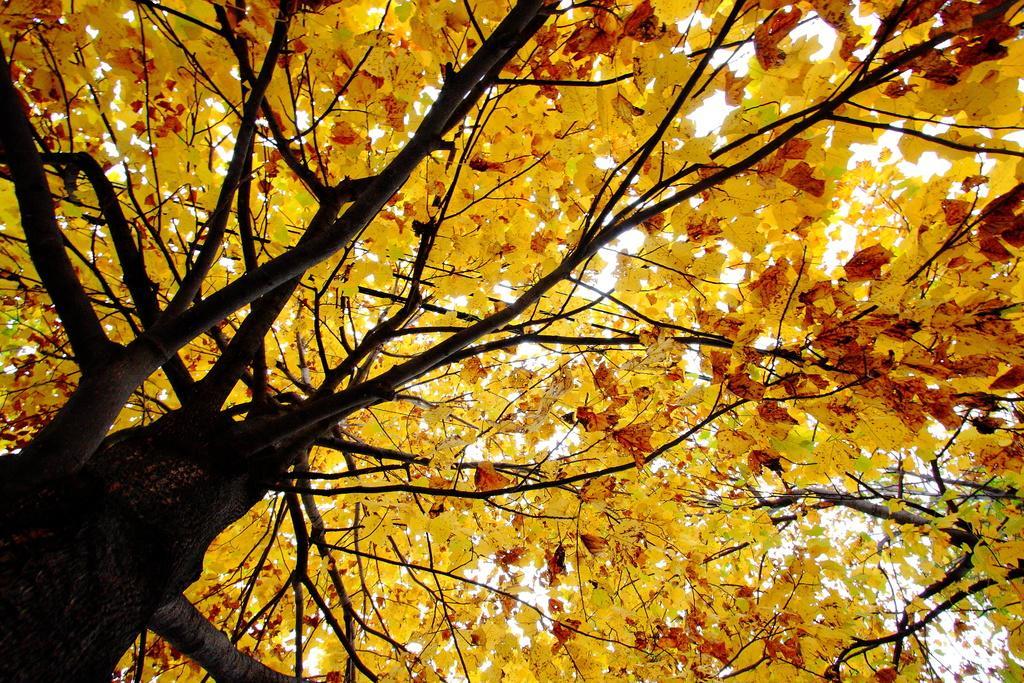Could you give a brief overview of what you see in this image? In this image we can see a tree and yellow leaves. 